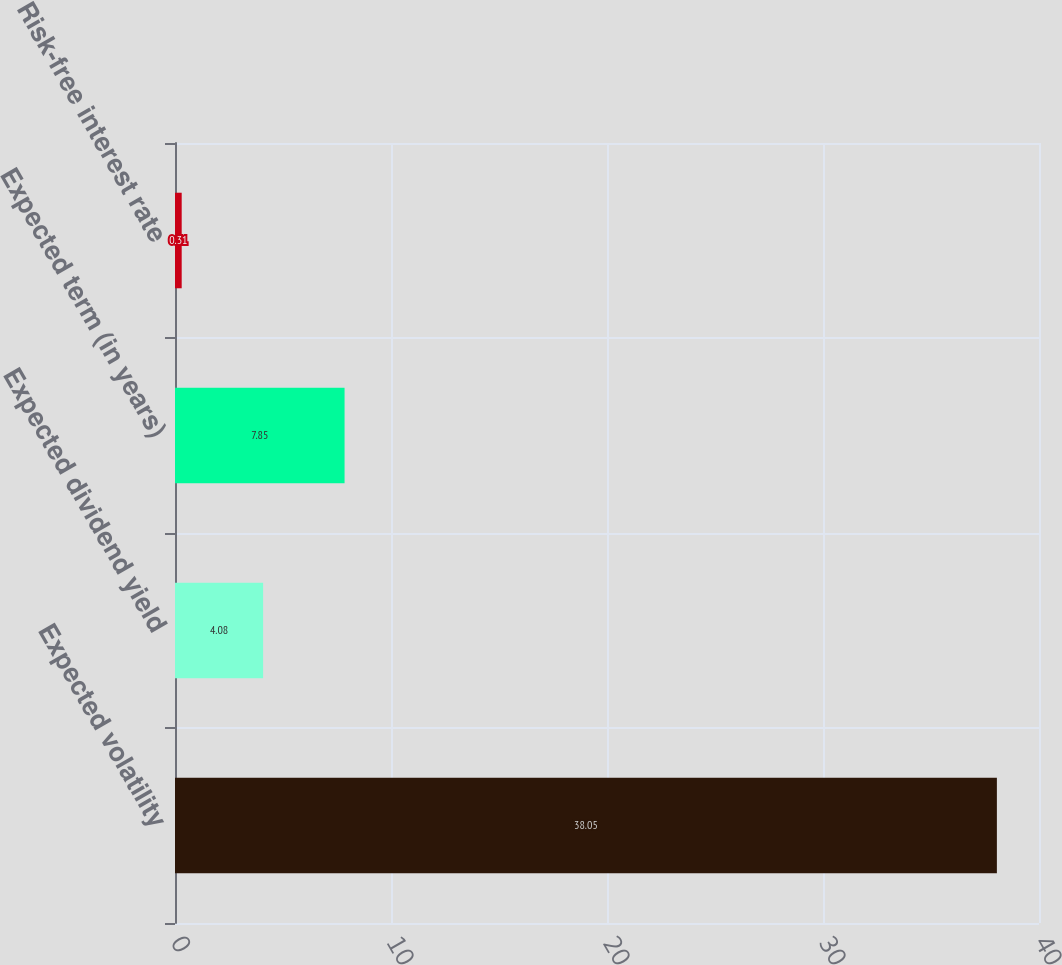<chart> <loc_0><loc_0><loc_500><loc_500><bar_chart><fcel>Expected volatility<fcel>Expected dividend yield<fcel>Expected term (in years)<fcel>Risk-free interest rate<nl><fcel>38.05<fcel>4.08<fcel>7.85<fcel>0.31<nl></chart> 